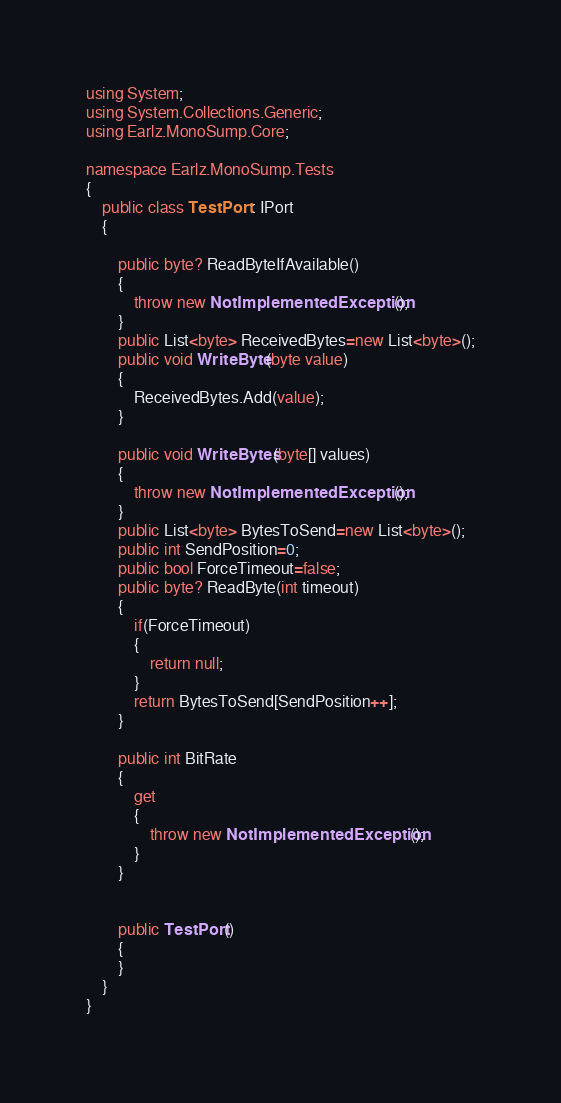<code> <loc_0><loc_0><loc_500><loc_500><_C#_>using System;
using System.Collections.Generic;
using Earlz.MonoSump.Core;

namespace Earlz.MonoSump.Tests
{
	public class TestPort : IPort
	{

		public byte? ReadByteIfAvailable()
		{
			throw new NotImplementedException();
		}
		public List<byte> ReceivedBytes=new List<byte>();
		public void WriteByte(byte value)
		{
			ReceivedBytes.Add(value);
		}

		public void WriteBytes(byte[] values)
		{
			throw new NotImplementedException();
		}
		public List<byte> BytesToSend=new List<byte>();
		public int SendPosition=0;
		public bool ForceTimeout=false;
		public byte? ReadByte(int timeout)
		{
			if(ForceTimeout)
			{
				return null;
			}
			return BytesToSend[SendPosition++];
		}

		public int BitRate
		{
			get
			{
				throw new NotImplementedException();
			}
		}


		public TestPort()
		{
		}
	}
}

</code> 